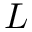Convert formula to latex. <formula><loc_0><loc_0><loc_500><loc_500>L</formula> 